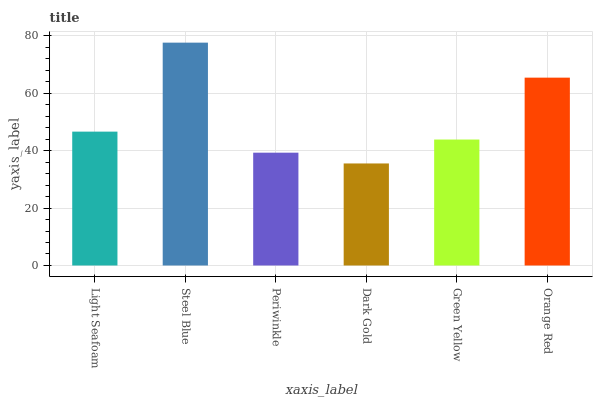Is Dark Gold the minimum?
Answer yes or no. Yes. Is Steel Blue the maximum?
Answer yes or no. Yes. Is Periwinkle the minimum?
Answer yes or no. No. Is Periwinkle the maximum?
Answer yes or no. No. Is Steel Blue greater than Periwinkle?
Answer yes or no. Yes. Is Periwinkle less than Steel Blue?
Answer yes or no. Yes. Is Periwinkle greater than Steel Blue?
Answer yes or no. No. Is Steel Blue less than Periwinkle?
Answer yes or no. No. Is Light Seafoam the high median?
Answer yes or no. Yes. Is Green Yellow the low median?
Answer yes or no. Yes. Is Green Yellow the high median?
Answer yes or no. No. Is Light Seafoam the low median?
Answer yes or no. No. 